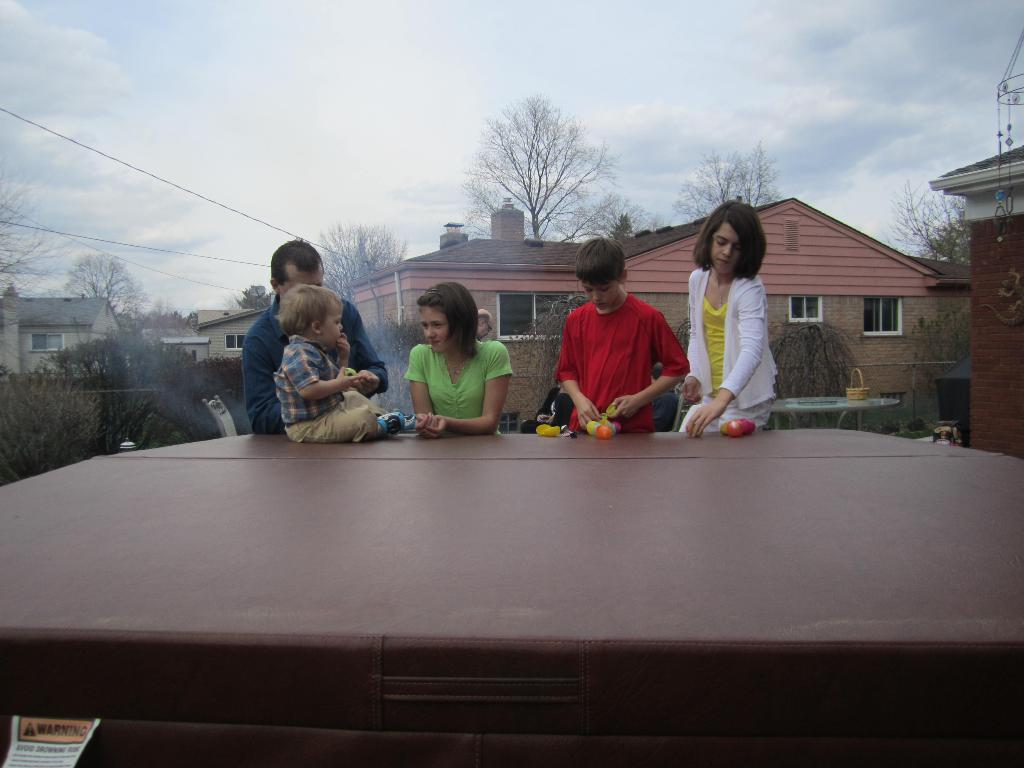What is the primary activity of the people in the image? The people in the image are standing, which suggests they might be observing or waiting for something. What is the position of the kid in the image? The kid is sitting on a surface in the image. What can be seen in front of the two people? Objects are visible in front of the two people, but their specific nature is not mentioned in the facts. What type of structures can be seen in the background of the image? There are houses in the background of the image. What type of natural elements can be seen in the background of the image? Trees, plants, and the sky are visible in the background of the image. What type of sock is the kid wearing in the image? There is no information about the kid's socks in the image, so it cannot be determined. 